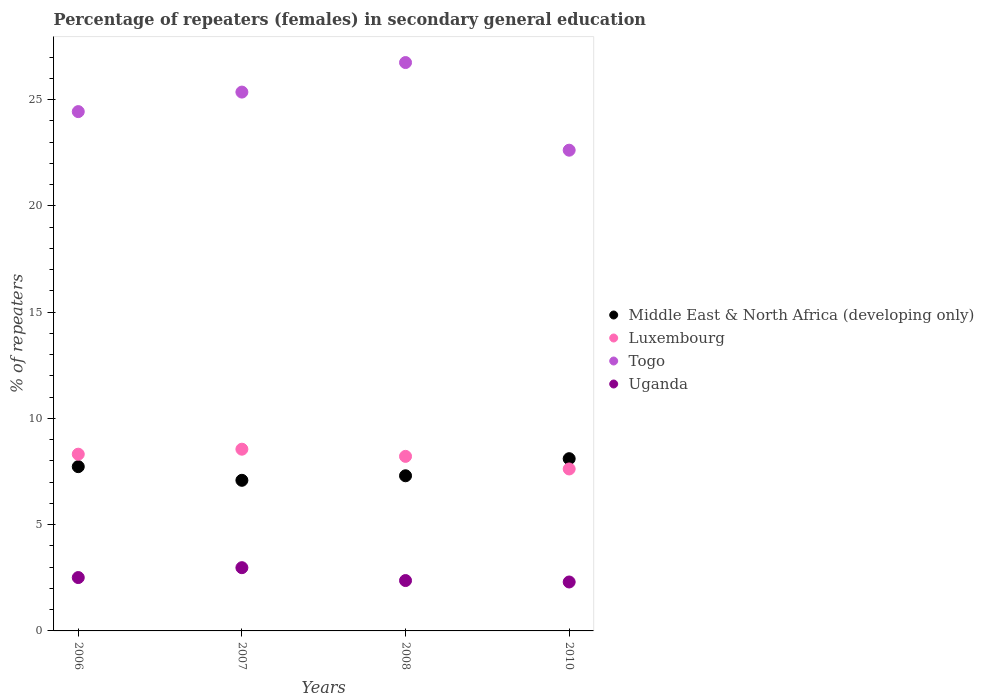How many different coloured dotlines are there?
Make the answer very short. 4. Is the number of dotlines equal to the number of legend labels?
Offer a very short reply. Yes. What is the percentage of female repeaters in Togo in 2008?
Offer a very short reply. 26.75. Across all years, what is the maximum percentage of female repeaters in Uganda?
Provide a succinct answer. 2.98. Across all years, what is the minimum percentage of female repeaters in Middle East & North Africa (developing only)?
Provide a succinct answer. 7.09. In which year was the percentage of female repeaters in Togo maximum?
Give a very brief answer. 2008. In which year was the percentage of female repeaters in Togo minimum?
Your answer should be compact. 2010. What is the total percentage of female repeaters in Togo in the graph?
Your answer should be very brief. 99.17. What is the difference between the percentage of female repeaters in Togo in 2008 and that in 2010?
Keep it short and to the point. 4.12. What is the difference between the percentage of female repeaters in Luxembourg in 2006 and the percentage of female repeaters in Uganda in 2008?
Keep it short and to the point. 5.95. What is the average percentage of female repeaters in Togo per year?
Offer a terse response. 24.79. In the year 2006, what is the difference between the percentage of female repeaters in Luxembourg and percentage of female repeaters in Uganda?
Offer a terse response. 5.81. What is the ratio of the percentage of female repeaters in Luxembourg in 2008 to that in 2010?
Offer a very short reply. 1.08. Is the percentage of female repeaters in Luxembourg in 2008 less than that in 2010?
Provide a succinct answer. No. Is the difference between the percentage of female repeaters in Luxembourg in 2006 and 2007 greater than the difference between the percentage of female repeaters in Uganda in 2006 and 2007?
Offer a very short reply. Yes. What is the difference between the highest and the second highest percentage of female repeaters in Togo?
Offer a terse response. 1.39. What is the difference between the highest and the lowest percentage of female repeaters in Togo?
Keep it short and to the point. 4.12. Is it the case that in every year, the sum of the percentage of female repeaters in Uganda and percentage of female repeaters in Togo  is greater than the sum of percentage of female repeaters in Luxembourg and percentage of female repeaters in Middle East & North Africa (developing only)?
Your answer should be compact. Yes. Is it the case that in every year, the sum of the percentage of female repeaters in Luxembourg and percentage of female repeaters in Uganda  is greater than the percentage of female repeaters in Togo?
Your answer should be compact. No. Does the percentage of female repeaters in Togo monotonically increase over the years?
Ensure brevity in your answer.  No. Is the percentage of female repeaters in Luxembourg strictly less than the percentage of female repeaters in Togo over the years?
Offer a very short reply. Yes. How many years are there in the graph?
Keep it short and to the point. 4. What is the difference between two consecutive major ticks on the Y-axis?
Provide a short and direct response. 5. Are the values on the major ticks of Y-axis written in scientific E-notation?
Provide a succinct answer. No. Does the graph contain grids?
Give a very brief answer. No. Where does the legend appear in the graph?
Offer a terse response. Center right. How many legend labels are there?
Provide a succinct answer. 4. What is the title of the graph?
Your response must be concise. Percentage of repeaters (females) in secondary general education. Does "Faeroe Islands" appear as one of the legend labels in the graph?
Ensure brevity in your answer.  No. What is the label or title of the X-axis?
Offer a terse response. Years. What is the label or title of the Y-axis?
Provide a succinct answer. % of repeaters. What is the % of repeaters in Middle East & North Africa (developing only) in 2006?
Provide a short and direct response. 7.73. What is the % of repeaters in Luxembourg in 2006?
Your response must be concise. 8.32. What is the % of repeaters in Togo in 2006?
Provide a short and direct response. 24.44. What is the % of repeaters in Uganda in 2006?
Your answer should be very brief. 2.51. What is the % of repeaters in Middle East & North Africa (developing only) in 2007?
Ensure brevity in your answer.  7.09. What is the % of repeaters in Luxembourg in 2007?
Offer a terse response. 8.55. What is the % of repeaters of Togo in 2007?
Offer a very short reply. 25.36. What is the % of repeaters of Uganda in 2007?
Give a very brief answer. 2.98. What is the % of repeaters of Middle East & North Africa (developing only) in 2008?
Offer a very short reply. 7.3. What is the % of repeaters in Luxembourg in 2008?
Offer a very short reply. 8.22. What is the % of repeaters in Togo in 2008?
Offer a very short reply. 26.75. What is the % of repeaters of Uganda in 2008?
Your answer should be compact. 2.37. What is the % of repeaters of Middle East & North Africa (developing only) in 2010?
Make the answer very short. 8.11. What is the % of repeaters in Luxembourg in 2010?
Keep it short and to the point. 7.62. What is the % of repeaters of Togo in 2010?
Give a very brief answer. 22.62. What is the % of repeaters in Uganda in 2010?
Your answer should be very brief. 2.3. Across all years, what is the maximum % of repeaters of Middle East & North Africa (developing only)?
Keep it short and to the point. 8.11. Across all years, what is the maximum % of repeaters of Luxembourg?
Provide a short and direct response. 8.55. Across all years, what is the maximum % of repeaters in Togo?
Offer a terse response. 26.75. Across all years, what is the maximum % of repeaters in Uganda?
Provide a short and direct response. 2.98. Across all years, what is the minimum % of repeaters of Middle East & North Africa (developing only)?
Make the answer very short. 7.09. Across all years, what is the minimum % of repeaters of Luxembourg?
Make the answer very short. 7.62. Across all years, what is the minimum % of repeaters in Togo?
Offer a terse response. 22.62. Across all years, what is the minimum % of repeaters of Uganda?
Offer a terse response. 2.3. What is the total % of repeaters of Middle East & North Africa (developing only) in the graph?
Give a very brief answer. 30.23. What is the total % of repeaters in Luxembourg in the graph?
Provide a succinct answer. 32.71. What is the total % of repeaters of Togo in the graph?
Your response must be concise. 99.17. What is the total % of repeaters of Uganda in the graph?
Your response must be concise. 10.16. What is the difference between the % of repeaters of Middle East & North Africa (developing only) in 2006 and that in 2007?
Give a very brief answer. 0.64. What is the difference between the % of repeaters of Luxembourg in 2006 and that in 2007?
Make the answer very short. -0.23. What is the difference between the % of repeaters in Togo in 2006 and that in 2007?
Make the answer very short. -0.92. What is the difference between the % of repeaters of Uganda in 2006 and that in 2007?
Your answer should be very brief. -0.46. What is the difference between the % of repeaters in Middle East & North Africa (developing only) in 2006 and that in 2008?
Your answer should be very brief. 0.43. What is the difference between the % of repeaters of Luxembourg in 2006 and that in 2008?
Make the answer very short. 0.1. What is the difference between the % of repeaters in Togo in 2006 and that in 2008?
Offer a terse response. -2.31. What is the difference between the % of repeaters in Uganda in 2006 and that in 2008?
Your answer should be very brief. 0.14. What is the difference between the % of repeaters in Middle East & North Africa (developing only) in 2006 and that in 2010?
Your response must be concise. -0.38. What is the difference between the % of repeaters of Luxembourg in 2006 and that in 2010?
Keep it short and to the point. 0.7. What is the difference between the % of repeaters of Togo in 2006 and that in 2010?
Make the answer very short. 1.82. What is the difference between the % of repeaters in Uganda in 2006 and that in 2010?
Keep it short and to the point. 0.21. What is the difference between the % of repeaters in Middle East & North Africa (developing only) in 2007 and that in 2008?
Keep it short and to the point. -0.21. What is the difference between the % of repeaters of Luxembourg in 2007 and that in 2008?
Offer a very short reply. 0.34. What is the difference between the % of repeaters of Togo in 2007 and that in 2008?
Keep it short and to the point. -1.39. What is the difference between the % of repeaters of Uganda in 2007 and that in 2008?
Your answer should be very brief. 0.61. What is the difference between the % of repeaters in Middle East & North Africa (developing only) in 2007 and that in 2010?
Ensure brevity in your answer.  -1.02. What is the difference between the % of repeaters of Luxembourg in 2007 and that in 2010?
Offer a terse response. 0.93. What is the difference between the % of repeaters of Togo in 2007 and that in 2010?
Offer a terse response. 2.73. What is the difference between the % of repeaters of Uganda in 2007 and that in 2010?
Your answer should be very brief. 0.67. What is the difference between the % of repeaters of Middle East & North Africa (developing only) in 2008 and that in 2010?
Make the answer very short. -0.8. What is the difference between the % of repeaters in Luxembourg in 2008 and that in 2010?
Provide a short and direct response. 0.59. What is the difference between the % of repeaters in Togo in 2008 and that in 2010?
Your answer should be compact. 4.12. What is the difference between the % of repeaters in Uganda in 2008 and that in 2010?
Make the answer very short. 0.07. What is the difference between the % of repeaters in Middle East & North Africa (developing only) in 2006 and the % of repeaters in Luxembourg in 2007?
Your response must be concise. -0.82. What is the difference between the % of repeaters of Middle East & North Africa (developing only) in 2006 and the % of repeaters of Togo in 2007?
Offer a terse response. -17.63. What is the difference between the % of repeaters of Middle East & North Africa (developing only) in 2006 and the % of repeaters of Uganda in 2007?
Keep it short and to the point. 4.75. What is the difference between the % of repeaters of Luxembourg in 2006 and the % of repeaters of Togo in 2007?
Give a very brief answer. -17.04. What is the difference between the % of repeaters in Luxembourg in 2006 and the % of repeaters in Uganda in 2007?
Offer a terse response. 5.34. What is the difference between the % of repeaters of Togo in 2006 and the % of repeaters of Uganda in 2007?
Make the answer very short. 21.46. What is the difference between the % of repeaters of Middle East & North Africa (developing only) in 2006 and the % of repeaters of Luxembourg in 2008?
Give a very brief answer. -0.48. What is the difference between the % of repeaters of Middle East & North Africa (developing only) in 2006 and the % of repeaters of Togo in 2008?
Keep it short and to the point. -19.02. What is the difference between the % of repeaters in Middle East & North Africa (developing only) in 2006 and the % of repeaters in Uganda in 2008?
Provide a succinct answer. 5.36. What is the difference between the % of repeaters of Luxembourg in 2006 and the % of repeaters of Togo in 2008?
Your answer should be compact. -18.43. What is the difference between the % of repeaters in Luxembourg in 2006 and the % of repeaters in Uganda in 2008?
Keep it short and to the point. 5.95. What is the difference between the % of repeaters in Togo in 2006 and the % of repeaters in Uganda in 2008?
Keep it short and to the point. 22.07. What is the difference between the % of repeaters of Middle East & North Africa (developing only) in 2006 and the % of repeaters of Luxembourg in 2010?
Give a very brief answer. 0.11. What is the difference between the % of repeaters in Middle East & North Africa (developing only) in 2006 and the % of repeaters in Togo in 2010?
Your answer should be very brief. -14.89. What is the difference between the % of repeaters of Middle East & North Africa (developing only) in 2006 and the % of repeaters of Uganda in 2010?
Your response must be concise. 5.43. What is the difference between the % of repeaters of Luxembourg in 2006 and the % of repeaters of Togo in 2010?
Keep it short and to the point. -14.31. What is the difference between the % of repeaters of Luxembourg in 2006 and the % of repeaters of Uganda in 2010?
Make the answer very short. 6.01. What is the difference between the % of repeaters of Togo in 2006 and the % of repeaters of Uganda in 2010?
Provide a short and direct response. 22.14. What is the difference between the % of repeaters of Middle East & North Africa (developing only) in 2007 and the % of repeaters of Luxembourg in 2008?
Give a very brief answer. -1.13. What is the difference between the % of repeaters in Middle East & North Africa (developing only) in 2007 and the % of repeaters in Togo in 2008?
Keep it short and to the point. -19.66. What is the difference between the % of repeaters in Middle East & North Africa (developing only) in 2007 and the % of repeaters in Uganda in 2008?
Provide a short and direct response. 4.72. What is the difference between the % of repeaters of Luxembourg in 2007 and the % of repeaters of Togo in 2008?
Your answer should be very brief. -18.2. What is the difference between the % of repeaters of Luxembourg in 2007 and the % of repeaters of Uganda in 2008?
Keep it short and to the point. 6.18. What is the difference between the % of repeaters of Togo in 2007 and the % of repeaters of Uganda in 2008?
Give a very brief answer. 22.99. What is the difference between the % of repeaters of Middle East & North Africa (developing only) in 2007 and the % of repeaters of Luxembourg in 2010?
Ensure brevity in your answer.  -0.53. What is the difference between the % of repeaters of Middle East & North Africa (developing only) in 2007 and the % of repeaters of Togo in 2010?
Provide a short and direct response. -15.54. What is the difference between the % of repeaters in Middle East & North Africa (developing only) in 2007 and the % of repeaters in Uganda in 2010?
Your answer should be very brief. 4.79. What is the difference between the % of repeaters in Luxembourg in 2007 and the % of repeaters in Togo in 2010?
Provide a succinct answer. -14.07. What is the difference between the % of repeaters in Luxembourg in 2007 and the % of repeaters in Uganda in 2010?
Provide a short and direct response. 6.25. What is the difference between the % of repeaters of Togo in 2007 and the % of repeaters of Uganda in 2010?
Keep it short and to the point. 23.06. What is the difference between the % of repeaters in Middle East & North Africa (developing only) in 2008 and the % of repeaters in Luxembourg in 2010?
Your answer should be very brief. -0.32. What is the difference between the % of repeaters of Middle East & North Africa (developing only) in 2008 and the % of repeaters of Togo in 2010?
Make the answer very short. -15.32. What is the difference between the % of repeaters of Middle East & North Africa (developing only) in 2008 and the % of repeaters of Uganda in 2010?
Your answer should be very brief. 5. What is the difference between the % of repeaters of Luxembourg in 2008 and the % of repeaters of Togo in 2010?
Your answer should be very brief. -14.41. What is the difference between the % of repeaters in Luxembourg in 2008 and the % of repeaters in Uganda in 2010?
Provide a short and direct response. 5.91. What is the difference between the % of repeaters of Togo in 2008 and the % of repeaters of Uganda in 2010?
Make the answer very short. 24.45. What is the average % of repeaters of Middle East & North Africa (developing only) per year?
Your answer should be very brief. 7.56. What is the average % of repeaters in Luxembourg per year?
Your answer should be compact. 8.18. What is the average % of repeaters of Togo per year?
Make the answer very short. 24.79. What is the average % of repeaters in Uganda per year?
Your answer should be compact. 2.54. In the year 2006, what is the difference between the % of repeaters in Middle East & North Africa (developing only) and % of repeaters in Luxembourg?
Ensure brevity in your answer.  -0.59. In the year 2006, what is the difference between the % of repeaters of Middle East & North Africa (developing only) and % of repeaters of Togo?
Keep it short and to the point. -16.71. In the year 2006, what is the difference between the % of repeaters in Middle East & North Africa (developing only) and % of repeaters in Uganda?
Make the answer very short. 5.22. In the year 2006, what is the difference between the % of repeaters in Luxembourg and % of repeaters in Togo?
Give a very brief answer. -16.12. In the year 2006, what is the difference between the % of repeaters in Luxembourg and % of repeaters in Uganda?
Make the answer very short. 5.81. In the year 2006, what is the difference between the % of repeaters in Togo and % of repeaters in Uganda?
Your answer should be very brief. 21.93. In the year 2007, what is the difference between the % of repeaters in Middle East & North Africa (developing only) and % of repeaters in Luxembourg?
Give a very brief answer. -1.46. In the year 2007, what is the difference between the % of repeaters in Middle East & North Africa (developing only) and % of repeaters in Togo?
Keep it short and to the point. -18.27. In the year 2007, what is the difference between the % of repeaters in Middle East & North Africa (developing only) and % of repeaters in Uganda?
Offer a terse response. 4.11. In the year 2007, what is the difference between the % of repeaters in Luxembourg and % of repeaters in Togo?
Your answer should be compact. -16.81. In the year 2007, what is the difference between the % of repeaters in Luxembourg and % of repeaters in Uganda?
Keep it short and to the point. 5.58. In the year 2007, what is the difference between the % of repeaters of Togo and % of repeaters of Uganda?
Offer a very short reply. 22.38. In the year 2008, what is the difference between the % of repeaters in Middle East & North Africa (developing only) and % of repeaters in Luxembourg?
Offer a very short reply. -0.91. In the year 2008, what is the difference between the % of repeaters in Middle East & North Africa (developing only) and % of repeaters in Togo?
Give a very brief answer. -19.45. In the year 2008, what is the difference between the % of repeaters in Middle East & North Africa (developing only) and % of repeaters in Uganda?
Your answer should be compact. 4.93. In the year 2008, what is the difference between the % of repeaters in Luxembourg and % of repeaters in Togo?
Ensure brevity in your answer.  -18.53. In the year 2008, what is the difference between the % of repeaters in Luxembourg and % of repeaters in Uganda?
Provide a succinct answer. 5.84. In the year 2008, what is the difference between the % of repeaters of Togo and % of repeaters of Uganda?
Offer a very short reply. 24.38. In the year 2010, what is the difference between the % of repeaters of Middle East & North Africa (developing only) and % of repeaters of Luxembourg?
Provide a short and direct response. 0.48. In the year 2010, what is the difference between the % of repeaters in Middle East & North Africa (developing only) and % of repeaters in Togo?
Offer a very short reply. -14.52. In the year 2010, what is the difference between the % of repeaters in Middle East & North Africa (developing only) and % of repeaters in Uganda?
Offer a very short reply. 5.8. In the year 2010, what is the difference between the % of repeaters in Luxembourg and % of repeaters in Togo?
Your answer should be very brief. -15. In the year 2010, what is the difference between the % of repeaters of Luxembourg and % of repeaters of Uganda?
Provide a short and direct response. 5.32. In the year 2010, what is the difference between the % of repeaters in Togo and % of repeaters in Uganda?
Offer a terse response. 20.32. What is the ratio of the % of repeaters of Middle East & North Africa (developing only) in 2006 to that in 2007?
Your answer should be very brief. 1.09. What is the ratio of the % of repeaters of Luxembourg in 2006 to that in 2007?
Give a very brief answer. 0.97. What is the ratio of the % of repeaters of Togo in 2006 to that in 2007?
Provide a succinct answer. 0.96. What is the ratio of the % of repeaters in Uganda in 2006 to that in 2007?
Offer a very short reply. 0.84. What is the ratio of the % of repeaters of Middle East & North Africa (developing only) in 2006 to that in 2008?
Your answer should be compact. 1.06. What is the ratio of the % of repeaters in Luxembourg in 2006 to that in 2008?
Offer a very short reply. 1.01. What is the ratio of the % of repeaters of Togo in 2006 to that in 2008?
Provide a short and direct response. 0.91. What is the ratio of the % of repeaters in Uganda in 2006 to that in 2008?
Your answer should be compact. 1.06. What is the ratio of the % of repeaters of Middle East & North Africa (developing only) in 2006 to that in 2010?
Your response must be concise. 0.95. What is the ratio of the % of repeaters of Luxembourg in 2006 to that in 2010?
Your response must be concise. 1.09. What is the ratio of the % of repeaters of Togo in 2006 to that in 2010?
Provide a short and direct response. 1.08. What is the ratio of the % of repeaters in Uganda in 2006 to that in 2010?
Your answer should be compact. 1.09. What is the ratio of the % of repeaters of Middle East & North Africa (developing only) in 2007 to that in 2008?
Keep it short and to the point. 0.97. What is the ratio of the % of repeaters of Luxembourg in 2007 to that in 2008?
Your answer should be compact. 1.04. What is the ratio of the % of repeaters in Togo in 2007 to that in 2008?
Your answer should be very brief. 0.95. What is the ratio of the % of repeaters in Uganda in 2007 to that in 2008?
Ensure brevity in your answer.  1.26. What is the ratio of the % of repeaters in Middle East & North Africa (developing only) in 2007 to that in 2010?
Give a very brief answer. 0.87. What is the ratio of the % of repeaters of Luxembourg in 2007 to that in 2010?
Offer a very short reply. 1.12. What is the ratio of the % of repeaters in Togo in 2007 to that in 2010?
Provide a succinct answer. 1.12. What is the ratio of the % of repeaters in Uganda in 2007 to that in 2010?
Give a very brief answer. 1.29. What is the ratio of the % of repeaters in Middle East & North Africa (developing only) in 2008 to that in 2010?
Make the answer very short. 0.9. What is the ratio of the % of repeaters of Luxembourg in 2008 to that in 2010?
Keep it short and to the point. 1.08. What is the ratio of the % of repeaters of Togo in 2008 to that in 2010?
Your answer should be compact. 1.18. What is the ratio of the % of repeaters of Uganda in 2008 to that in 2010?
Provide a succinct answer. 1.03. What is the difference between the highest and the second highest % of repeaters in Middle East & North Africa (developing only)?
Your answer should be very brief. 0.38. What is the difference between the highest and the second highest % of repeaters in Luxembourg?
Provide a short and direct response. 0.23. What is the difference between the highest and the second highest % of repeaters of Togo?
Offer a terse response. 1.39. What is the difference between the highest and the second highest % of repeaters of Uganda?
Provide a short and direct response. 0.46. What is the difference between the highest and the lowest % of repeaters in Middle East & North Africa (developing only)?
Provide a short and direct response. 1.02. What is the difference between the highest and the lowest % of repeaters of Luxembourg?
Keep it short and to the point. 0.93. What is the difference between the highest and the lowest % of repeaters of Togo?
Provide a short and direct response. 4.12. What is the difference between the highest and the lowest % of repeaters in Uganda?
Offer a terse response. 0.67. 